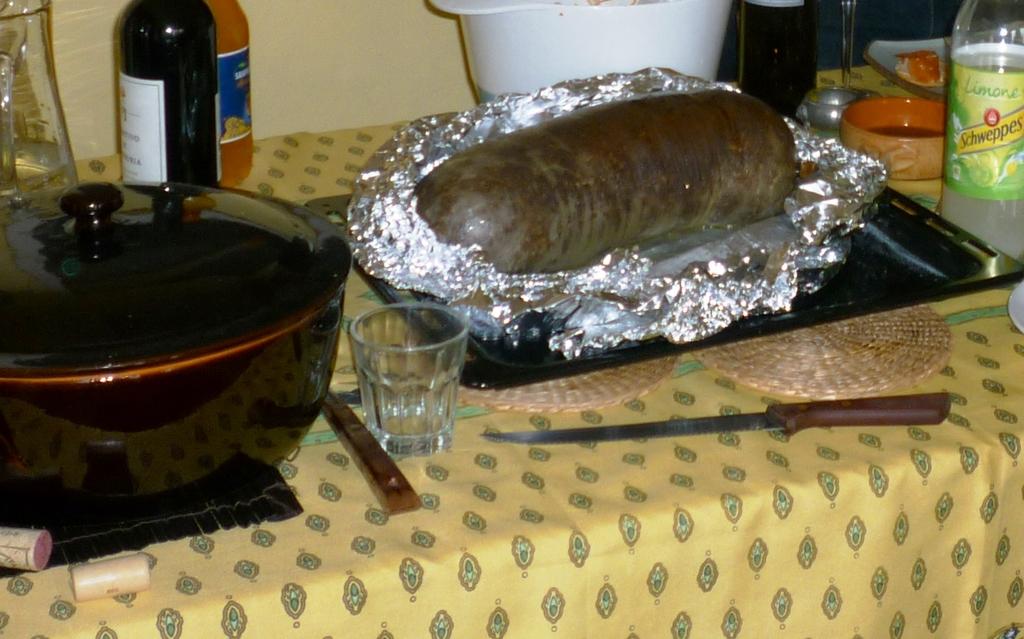What brand is the bottle with the green label?
Keep it short and to the point. Schweppes. What flavor is the schweppes?
Ensure brevity in your answer.  Limone. 